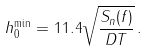Convert formula to latex. <formula><loc_0><loc_0><loc_500><loc_500>h _ { 0 } ^ { \min } = 1 1 . 4 \sqrt { \frac { S _ { n } ( f ) } { D T } } \, .</formula> 